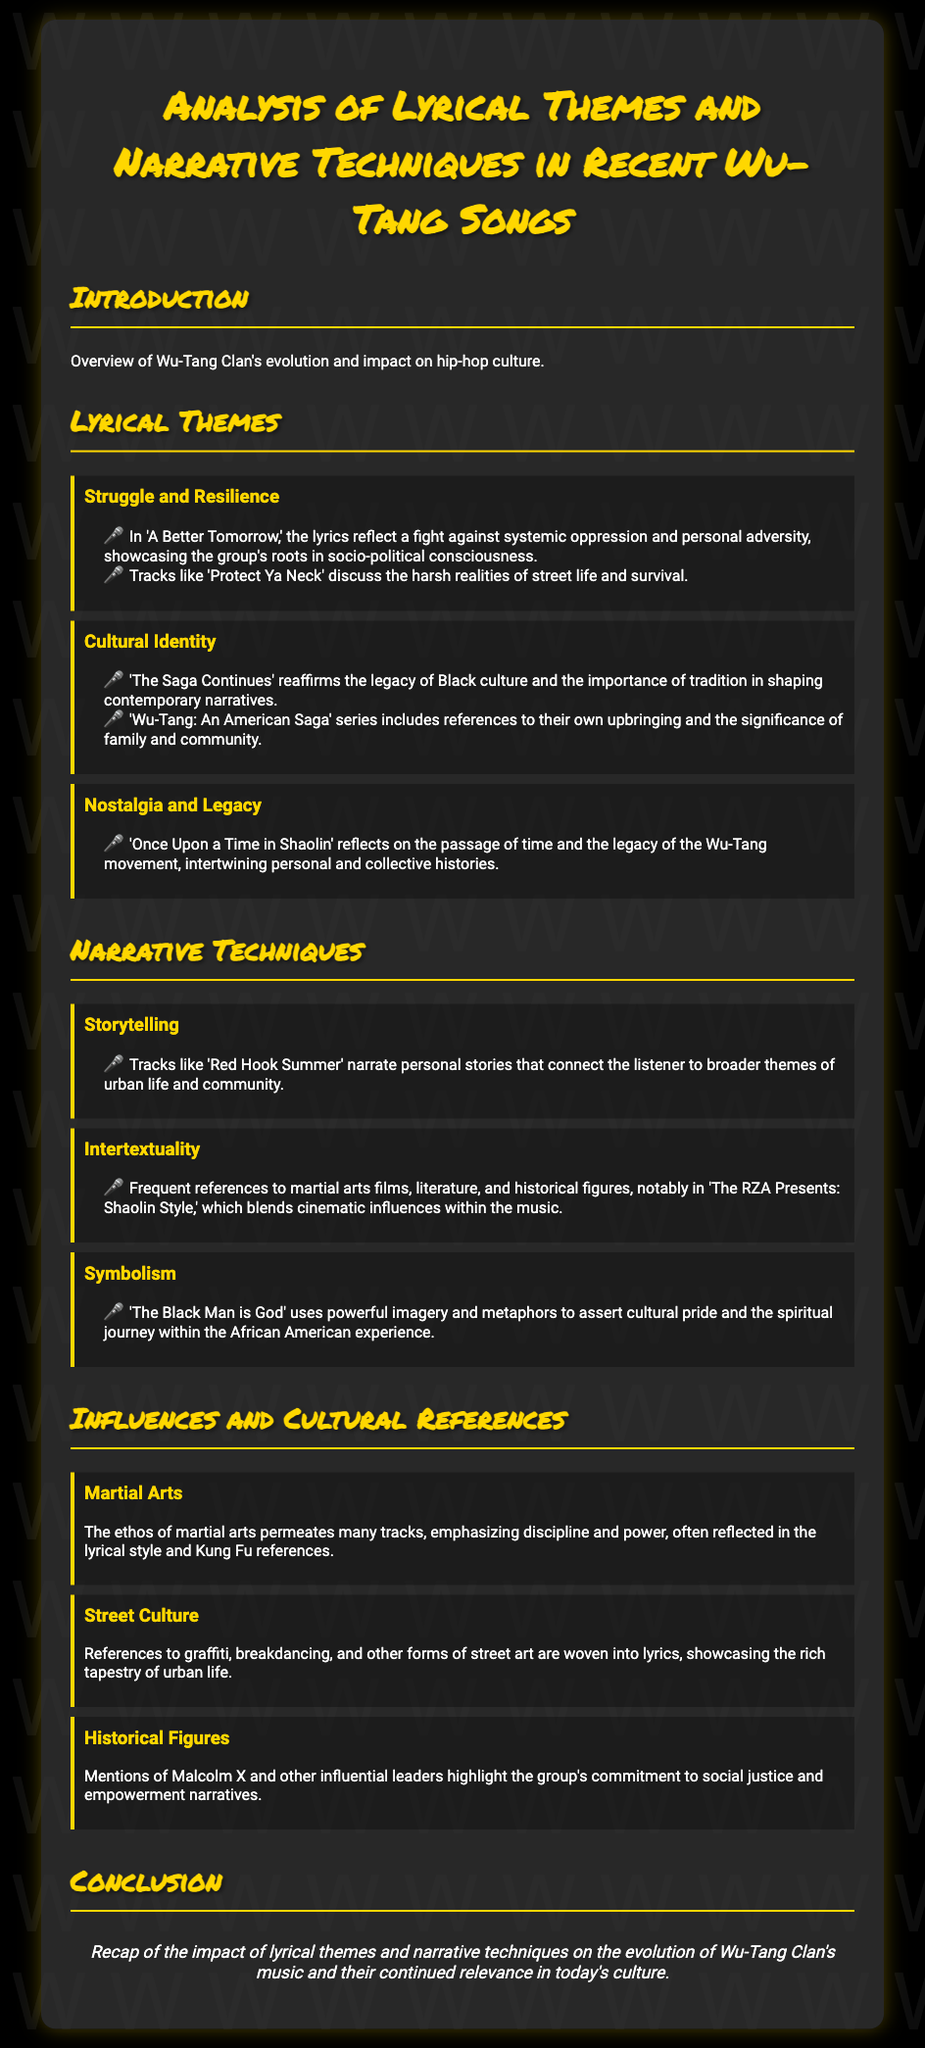What are the three main lyrical themes discussed? The document lists Struggle and Resilience, Cultural Identity, and Nostalgia and Legacy as the three main lyrical themes.
Answer: Struggle and Resilience, Cultural Identity, Nostalgia and Legacy Which song reflects on the legacy of the Wu-Tang movement? The song 'Once Upon a Time in Shaolin' is mentioned as reflecting on the passage of time and the legacy of Wu-Tang.
Answer: Once Upon a Time in Shaolin What narrative technique is used in 'Red Hook Summer'? The narrative technique used in 'Red Hook Summer' is storytelling, which connects personal stories to broader themes.
Answer: Storytelling How does the document describe the influence of martial arts? The document states that the ethos of martial arts emphasizes discipline and power, often reflected in the lyrics.
Answer: Discipline and power Which historical figure is mentioned in relation to social justice? Malcolm X is mentioned as a reference to social justice and empowerment narratives in the document.
Answer: Malcolm X What do the lyrics of 'The Black Man is God' focus on? The lyrics focus on powerful imagery and metaphors that assert cultural pride and the spiritual journey.
Answer: Cultural pride and spiritual journey In what year was the Wu-Tang Clan's impact on hip-hop culture discussed? The document does not specify a year but discusses the evolution and impact of Wu-Tang Clan overall.
Answer: Not specified What form of art do the lyrics reference besides music? The lyrics reference graffiti and breakdancing as forms of street art woven into their lyrics.
Answer: Graffiti and breakdancing What is the overall conclusion of the document? The conclusion recaps the impact of lyrical themes and narrative techniques on the evolution of Wu-Tang Clan's music.
Answer: Impact of lyrical themes and narrative techniques 